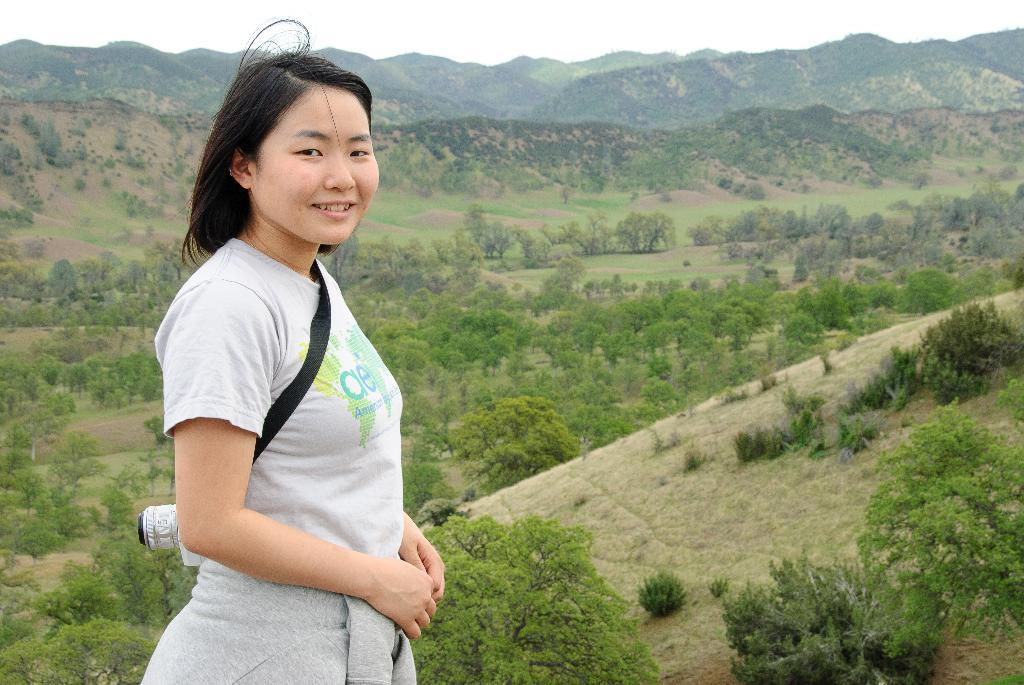Who is the main subject in the image? There is a woman in the image. Where is the woman positioned in the image? The woman is towards the left side of the image. What is the woman wearing? The woman is wearing a grey top and a grey jacket. What is the woman holding in the image? The woman is carrying a camera. What can be seen in the background of the image? There are hills with trees in the background of the image. What type of skin condition can be seen on the woman's face in the image? There is no indication of any skin condition on the woman's face in the image. What things are the woman using to grow her own food in the image? There is no indication of any gardening or food-growing activities in the image. 